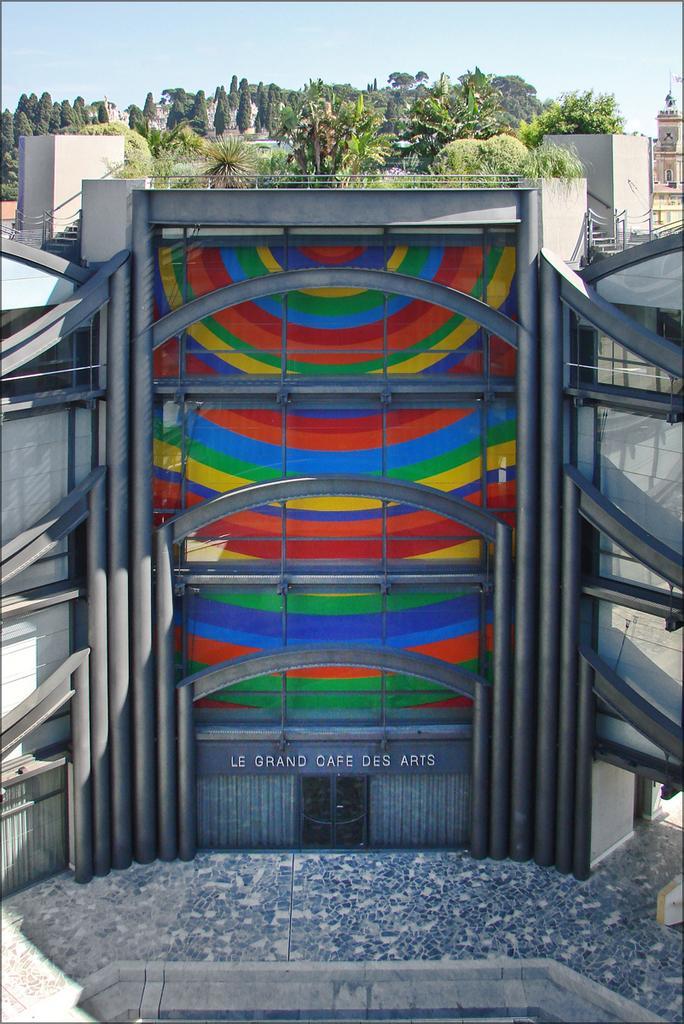Describe this image in one or two sentences. In this picture we can see building, trees and sky. Something written on this building. These are designed glass walls. 